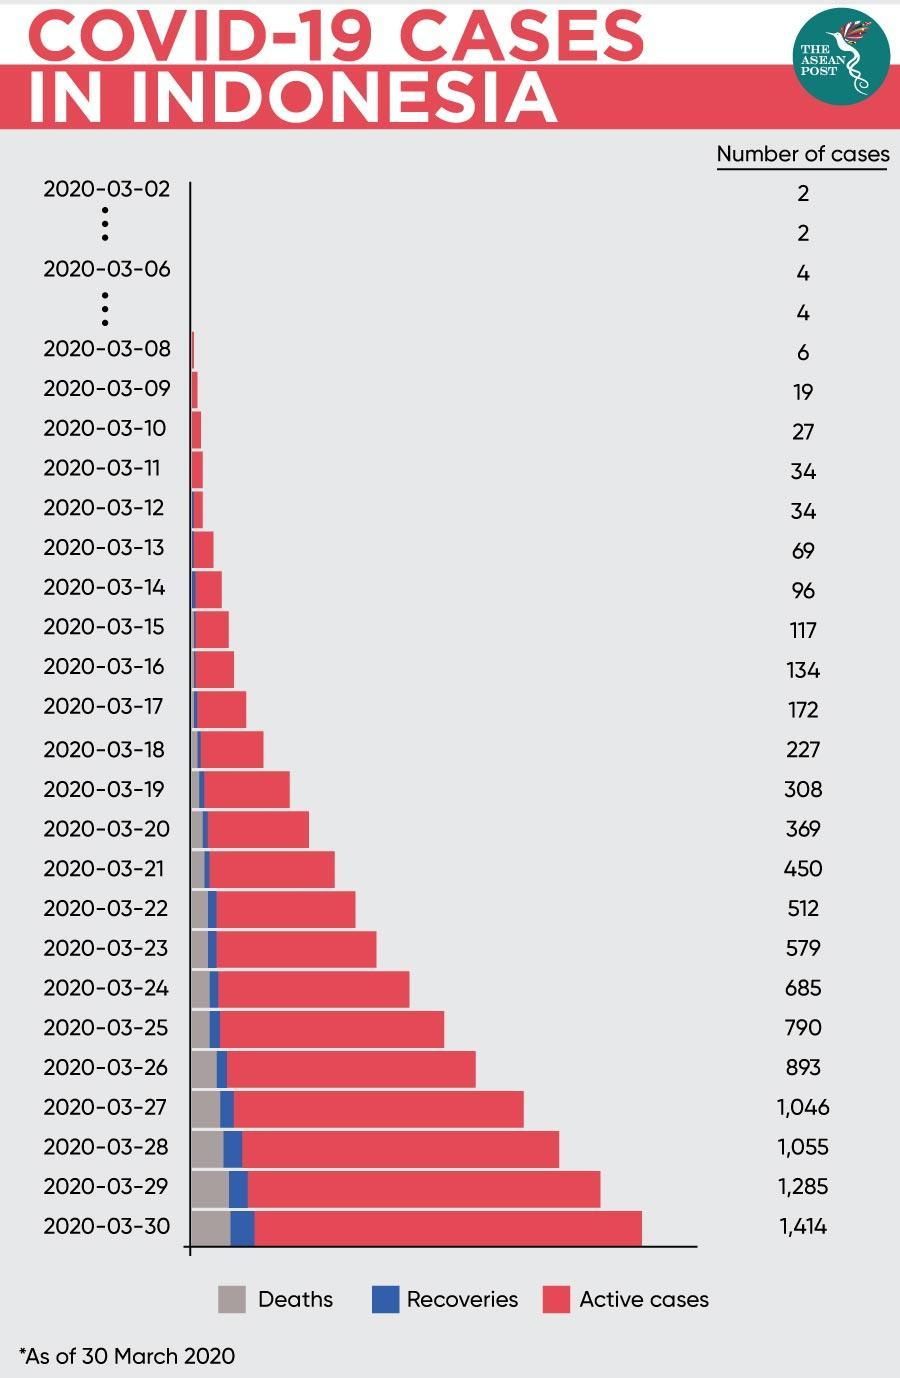How many Covid-19 cases were reported in Indonesia as on 28/03/20?
Answer the question with a short phrase. 1,055 How many Covid-19 cases were reported in Indonesia as on 30/03/20? 1,414 